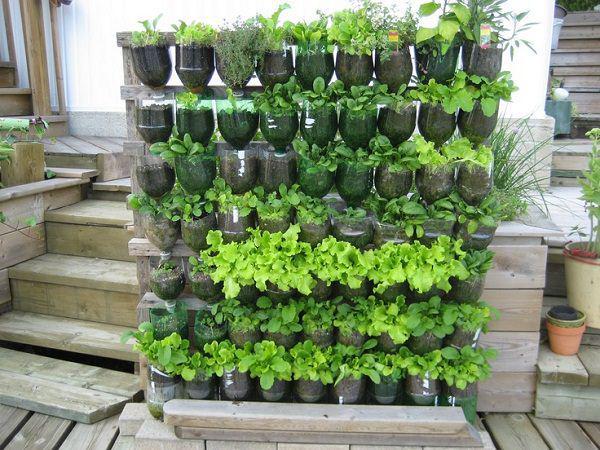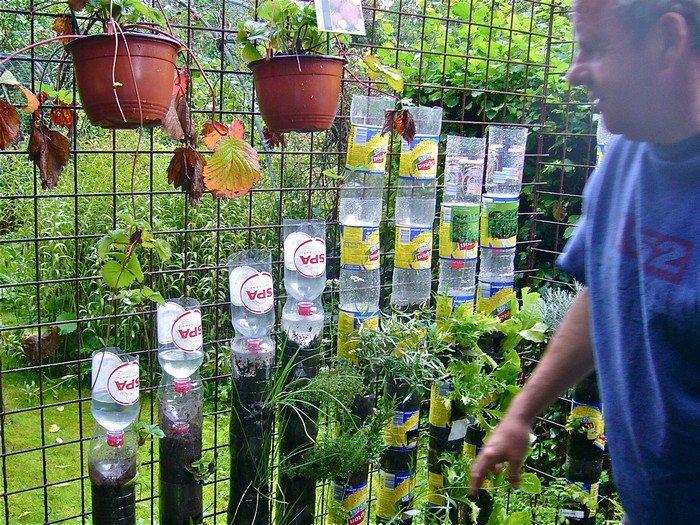The first image is the image on the left, the second image is the image on the right. For the images displayed, is the sentence "One image shows a man in a blue shirt standing in front of two hanging orange planters and a row of cylinder shapes topped with up-ended plastic bottles." factually correct? Answer yes or no. Yes. The first image is the image on the left, the second image is the image on the right. Analyze the images presented: Is the assertion "A man in a blue shirt is tending to a garden in the image on the right." valid? Answer yes or no. Yes. 